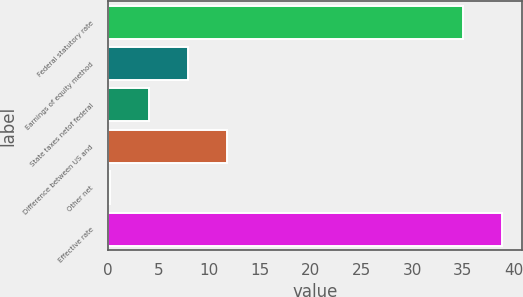Convert chart. <chart><loc_0><loc_0><loc_500><loc_500><bar_chart><fcel>Federal statutory rate<fcel>Earnings of equity method<fcel>State taxes netof federal<fcel>Difference between US and<fcel>Other net<fcel>Effective rate<nl><fcel>35<fcel>7.92<fcel>4.06<fcel>11.78<fcel>0.2<fcel>38.86<nl></chart> 